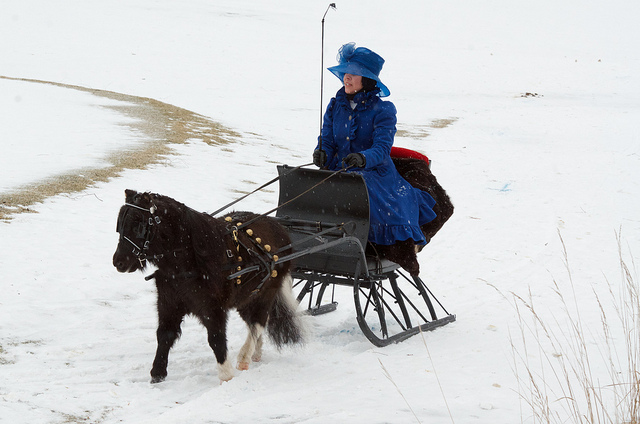What can you tell me about the sled design? The sled has a classic design with a single bench seat and an open frame. It's equipped with runners that are suited for gliding over snow. The harness attached to the pony is also ornate, suggesting that both the sled and the harness are designed for special occasions or for show. 